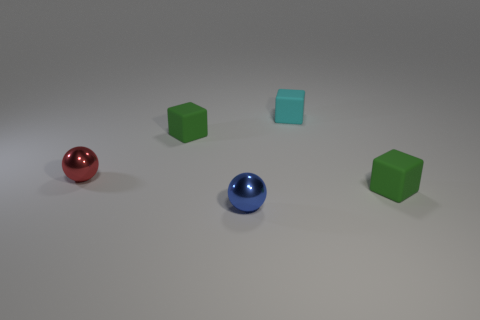How many green cubes must be subtracted to get 1 green cubes? 1 Subtract all balls. How many objects are left? 3 Subtract 2 balls. How many balls are left? 0 Subtract all green balls. Subtract all green blocks. How many balls are left? 2 Subtract all red spheres. How many green blocks are left? 2 Subtract all red metal objects. Subtract all small blue matte cylinders. How many objects are left? 4 Add 4 small blue balls. How many small blue balls are left? 5 Add 3 small green rubber blocks. How many small green rubber blocks exist? 5 Add 2 green matte things. How many objects exist? 7 Subtract all green blocks. How many blocks are left? 1 